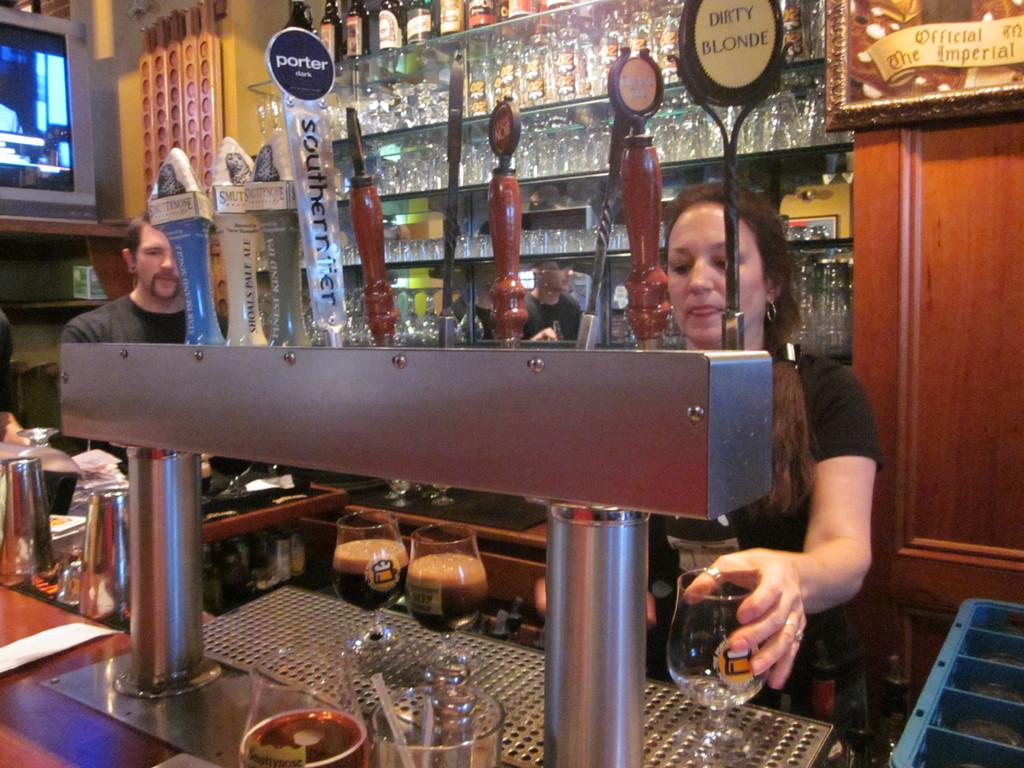What type of blonde is it?
Make the answer very short. Dirty. 